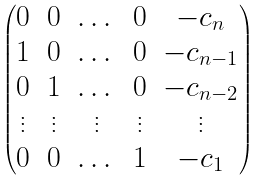<formula> <loc_0><loc_0><loc_500><loc_500>\begin{pmatrix} 0 & 0 & \dots & 0 & - c _ { n } \\ 1 & 0 & \dots & 0 & - c _ { n - 1 } \\ 0 & 1 & \dots & 0 & - c _ { n - 2 } \\ \vdots & \vdots & \vdots & \vdots & \vdots \\ 0 & 0 & \dots & 1 & - c _ { 1 } \end{pmatrix}</formula> 